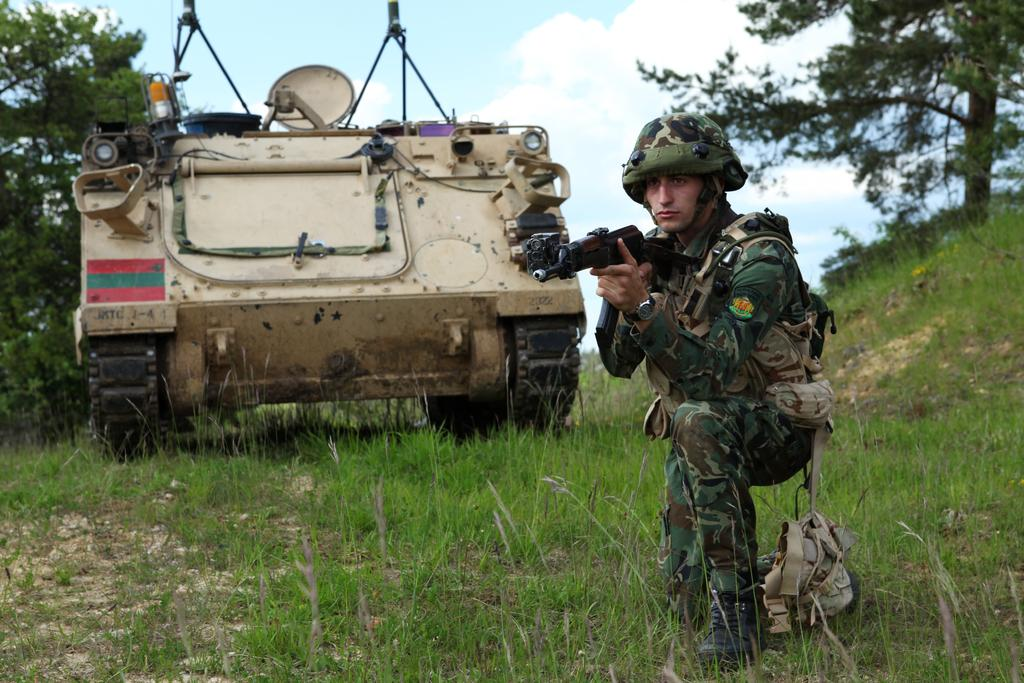What is the main subject of the image? There is a person in the image. What is the person wearing? The person is wearing a military dress. What is the person doing in the image? The person is crouching and holding a gun in their hands. What type of vehicle is present in the image? There is a panzer beside the person. What can be seen in the background of the image? There are trees on either side of the person. How many forks are visible in the image? There are no forks present in the image. What type of attraction is the person visiting in the image? There is no indication of an attraction in the image; it features a person in military dress crouching beside a panzer. 